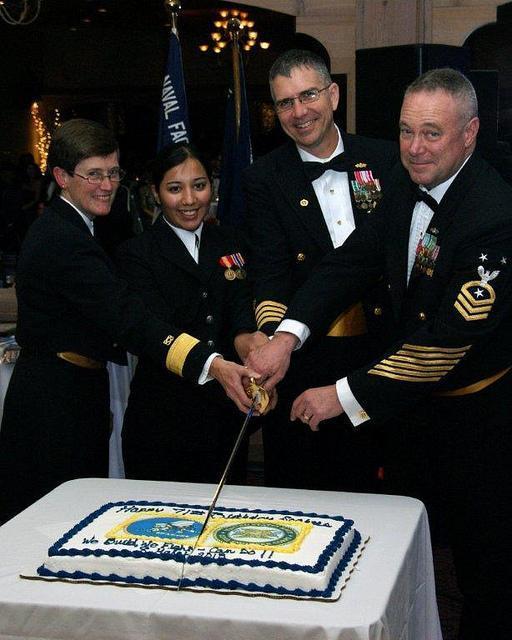How many people are cutting the cake?
Give a very brief answer. 4. How many people are wearing glasses?
Give a very brief answer. 2. How many people are in the photo?
Give a very brief answer. 4. How many chairs can be seen?
Give a very brief answer. 0. 